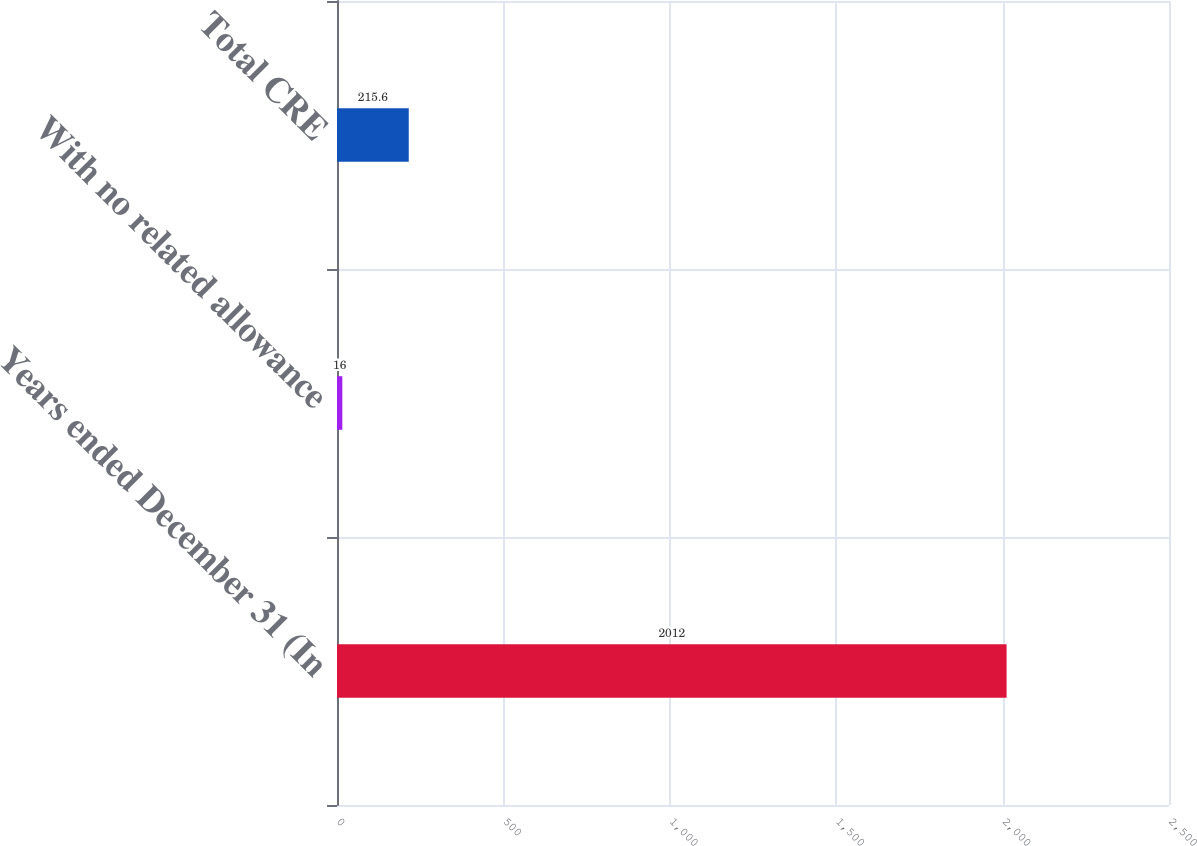Convert chart. <chart><loc_0><loc_0><loc_500><loc_500><bar_chart><fcel>Years ended December 31 (In<fcel>With no related allowance<fcel>Total CRE<nl><fcel>2012<fcel>16<fcel>215.6<nl></chart> 